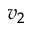Convert formula to latex. <formula><loc_0><loc_0><loc_500><loc_500>v _ { 2 }</formula> 